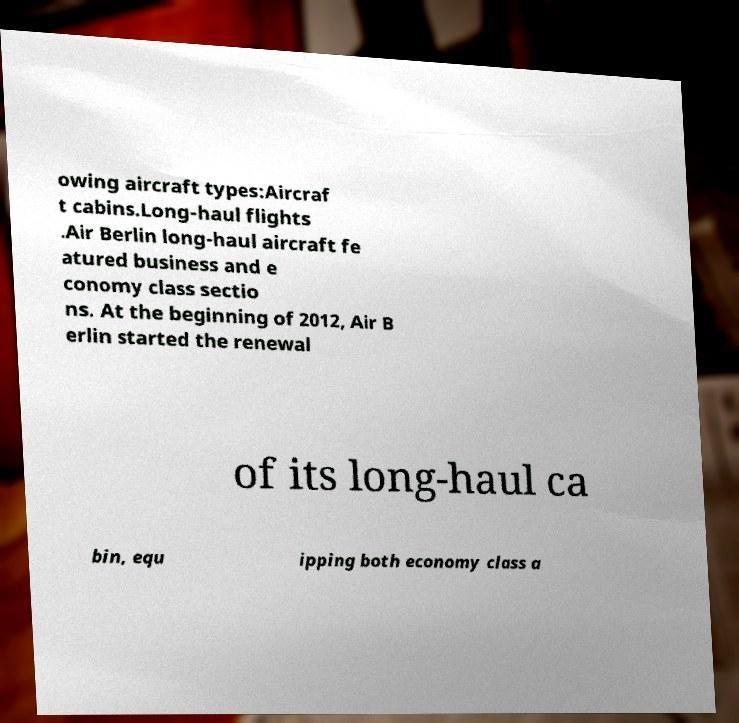Can you accurately transcribe the text from the provided image for me? owing aircraft types:Aircraf t cabins.Long-haul flights .Air Berlin long-haul aircraft fe atured business and e conomy class sectio ns. At the beginning of 2012, Air B erlin started the renewal of its long-haul ca bin, equ ipping both economy class a 